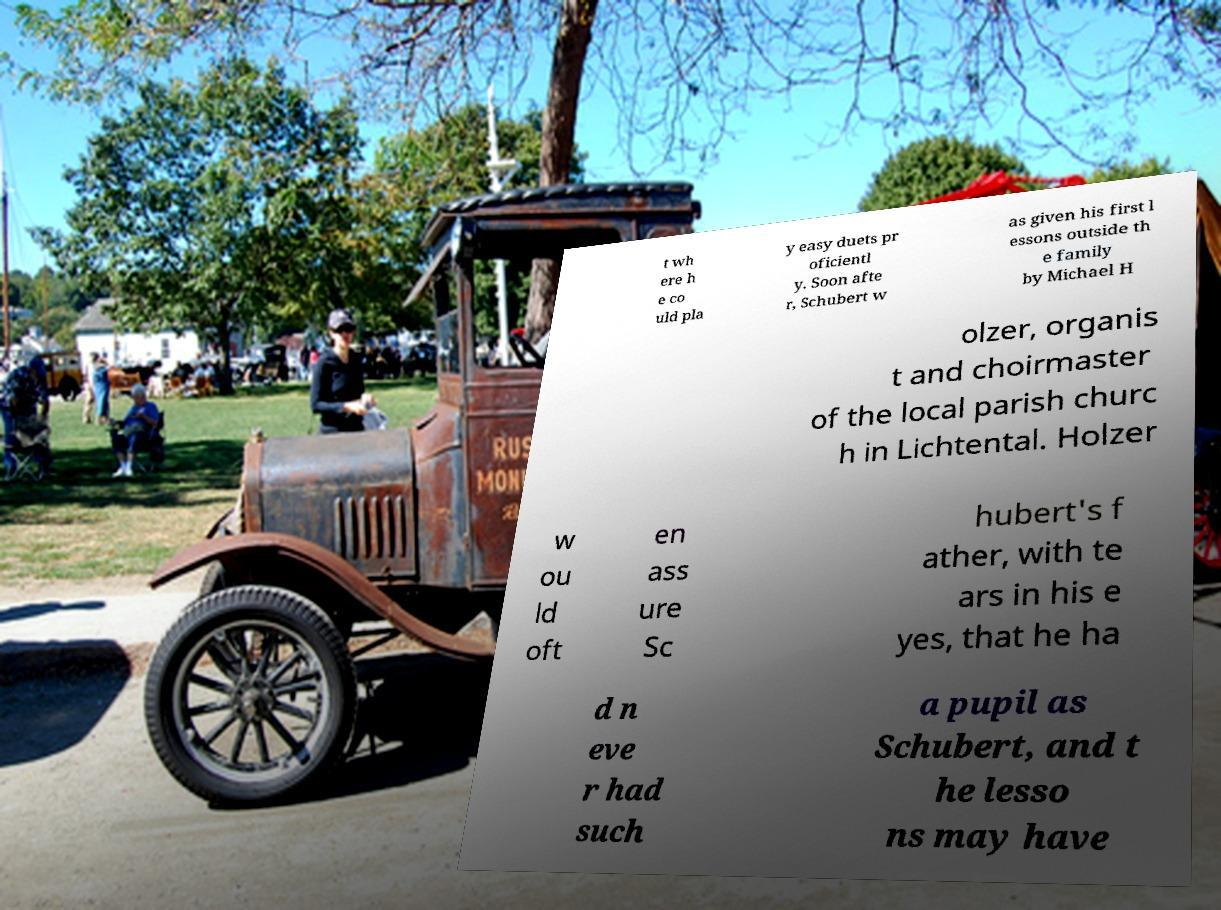I need the written content from this picture converted into text. Can you do that? t wh ere h e co uld pla y easy duets pr oficientl y. Soon afte r, Schubert w as given his first l essons outside th e family by Michael H olzer, organis t and choirmaster of the local parish churc h in Lichtental. Holzer w ou ld oft en ass ure Sc hubert's f ather, with te ars in his e yes, that he ha d n eve r had such a pupil as Schubert, and t he lesso ns may have 